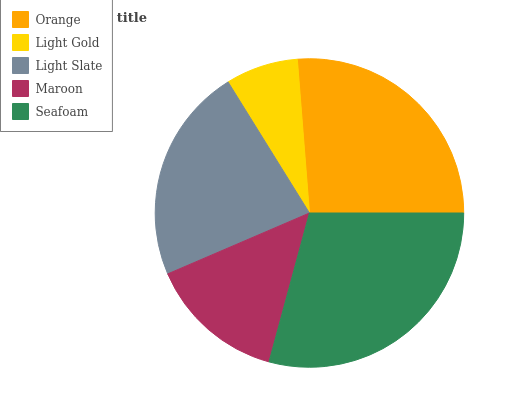Is Light Gold the minimum?
Answer yes or no. Yes. Is Seafoam the maximum?
Answer yes or no. Yes. Is Light Slate the minimum?
Answer yes or no. No. Is Light Slate the maximum?
Answer yes or no. No. Is Light Slate greater than Light Gold?
Answer yes or no. Yes. Is Light Gold less than Light Slate?
Answer yes or no. Yes. Is Light Gold greater than Light Slate?
Answer yes or no. No. Is Light Slate less than Light Gold?
Answer yes or no. No. Is Light Slate the high median?
Answer yes or no. Yes. Is Light Slate the low median?
Answer yes or no. Yes. Is Orange the high median?
Answer yes or no. No. Is Orange the low median?
Answer yes or no. No. 